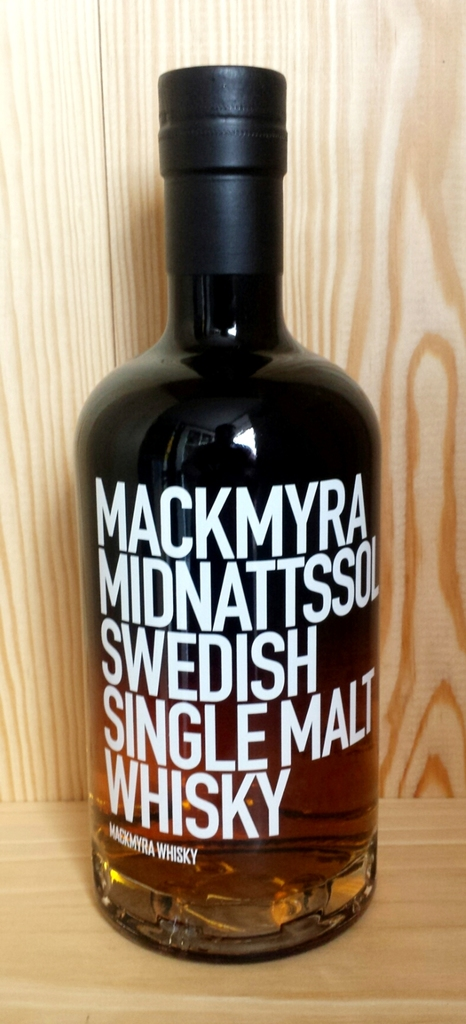What tasting notes might one expect from Mackmyra Midnattssol based on its color and presentation? Based on its rich amber color and premium presentation, one might expect Mackmyra Midnattssol to have a profile of light fruitiness with hints of vanilla and oak. The vibrant color often indicates a good balance of sweetness and spice, possibly with undertones of dried fruits and a smooth, warming finish that characterizes many high-quality single malts. 